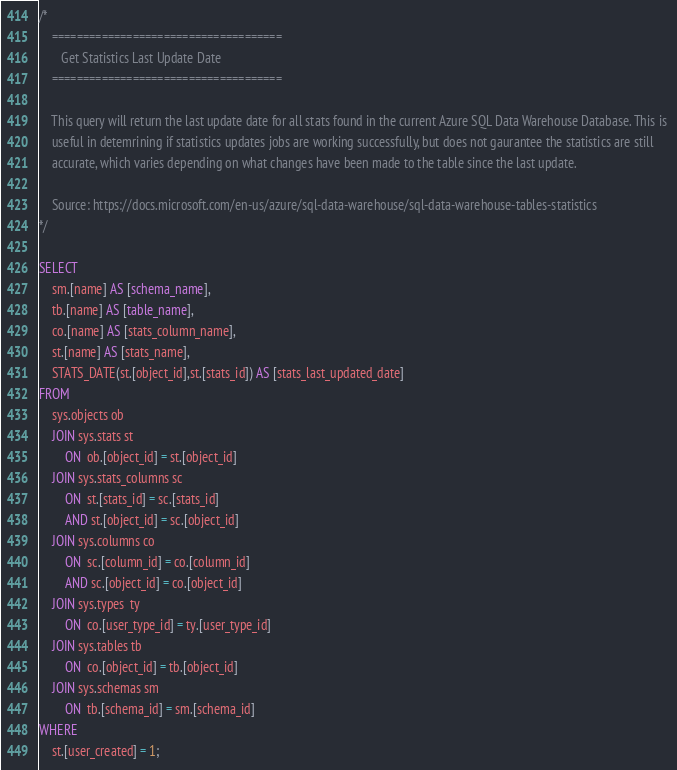<code> <loc_0><loc_0><loc_500><loc_500><_SQL_>/*
	=====================================
	   Get Statistics Last Update Date 
	=====================================

	This query will return the last update date for all stats found in the current Azure SQL Data Warehouse Database. This is 
	useful in detemrining if statistics updates jobs are working successfully, but does not gaurantee the statistics are still 
	accurate, which varies depending on what changes have been made to the table since the last update.
	
	Source: https://docs.microsoft.com/en-us/azure/sql-data-warehouse/sql-data-warehouse-tables-statistics
*/

SELECT
    sm.[name] AS [schema_name],
    tb.[name] AS [table_name],
    co.[name] AS [stats_column_name],
    st.[name] AS [stats_name],
    STATS_DATE(st.[object_id],st.[stats_id]) AS [stats_last_updated_date]
FROM
    sys.objects ob
    JOIN sys.stats st
        ON  ob.[object_id] = st.[object_id]
    JOIN sys.stats_columns sc    
        ON  st.[stats_id] = sc.[stats_id]
        AND st.[object_id] = sc.[object_id]
    JOIN sys.columns co    
        ON  sc.[column_id] = co.[column_id]
        AND sc.[object_id] = co.[object_id]
    JOIN sys.types  ty    
        ON  co.[user_type_id] = ty.[user_type_id]
    JOIN sys.tables tb    
        ON  co.[object_id] = tb.[object_id]
    JOIN sys.schemas sm    
        ON  tb.[schema_id] = sm.[schema_id]
WHERE
    st.[user_created] = 1;</code> 